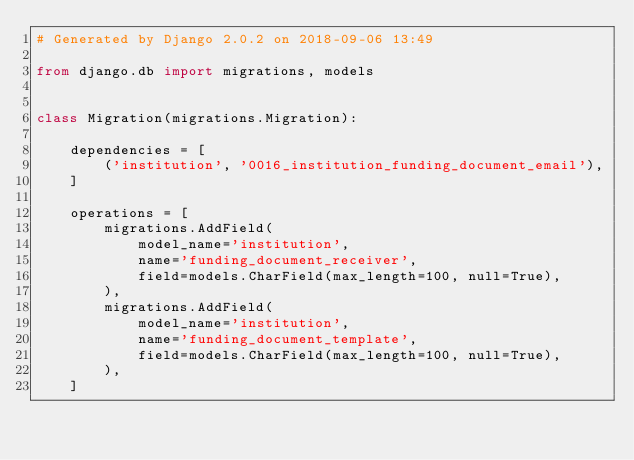Convert code to text. <code><loc_0><loc_0><loc_500><loc_500><_Python_># Generated by Django 2.0.2 on 2018-09-06 13:49

from django.db import migrations, models


class Migration(migrations.Migration):

    dependencies = [
        ('institution', '0016_institution_funding_document_email'),
    ]

    operations = [
        migrations.AddField(
            model_name='institution',
            name='funding_document_receiver',
            field=models.CharField(max_length=100, null=True),
        ),
        migrations.AddField(
            model_name='institution',
            name='funding_document_template',
            field=models.CharField(max_length=100, null=True),
        ),
    ]
</code> 